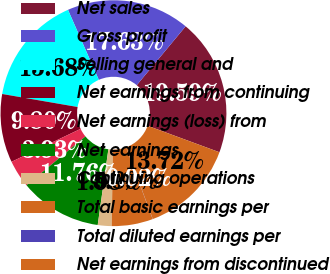Convert chart to OTSL. <chart><loc_0><loc_0><loc_500><loc_500><pie_chart><fcel>Net sales<fcel>Gross profit<fcel>Selling general and<fcel>Net earnings from continuing<fcel>Net earnings (loss) from<fcel>Net earnings<fcel>Continuing operations<fcel>Total basic earnings per<fcel>Total diluted earnings per<fcel>Net earnings from discontinued<nl><fcel>19.59%<fcel>17.63%<fcel>15.68%<fcel>9.8%<fcel>3.93%<fcel>11.76%<fcel>1.98%<fcel>5.89%<fcel>0.02%<fcel>13.72%<nl></chart> 